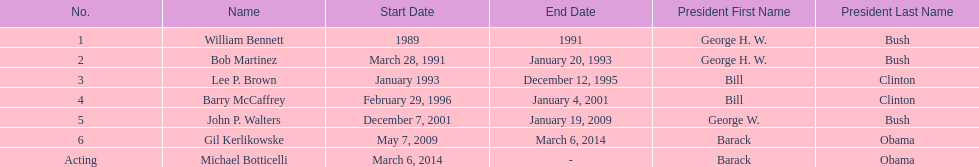Would you be able to parse every entry in this table? {'header': ['No.', 'Name', 'Start Date', 'End Date', 'President First Name', 'President Last Name'], 'rows': [['1', 'William Bennett', '1989', '1991', 'George H. W.', 'Bush'], ['2', 'Bob Martinez', 'March 28, 1991', 'January 20, 1993', 'George H. W.', 'Bush'], ['3', 'Lee P. Brown', 'January 1993', 'December 12, 1995', 'Bill', 'Clinton'], ['4', 'Barry McCaffrey', 'February 29, 1996', 'January 4, 2001', 'Bill', 'Clinton'], ['5', 'John P. Walters', 'December 7, 2001', 'January 19, 2009', 'George W.', 'Bush'], ['6', 'Gil Kerlikowske', 'May 7, 2009', 'March 6, 2014', 'Barack', 'Obama'], ['Acting', 'Michael Botticelli', 'March 6, 2014', '-', 'Barack', 'Obama']]} Who was the next appointed director after lee p. brown? Barry McCaffrey. 